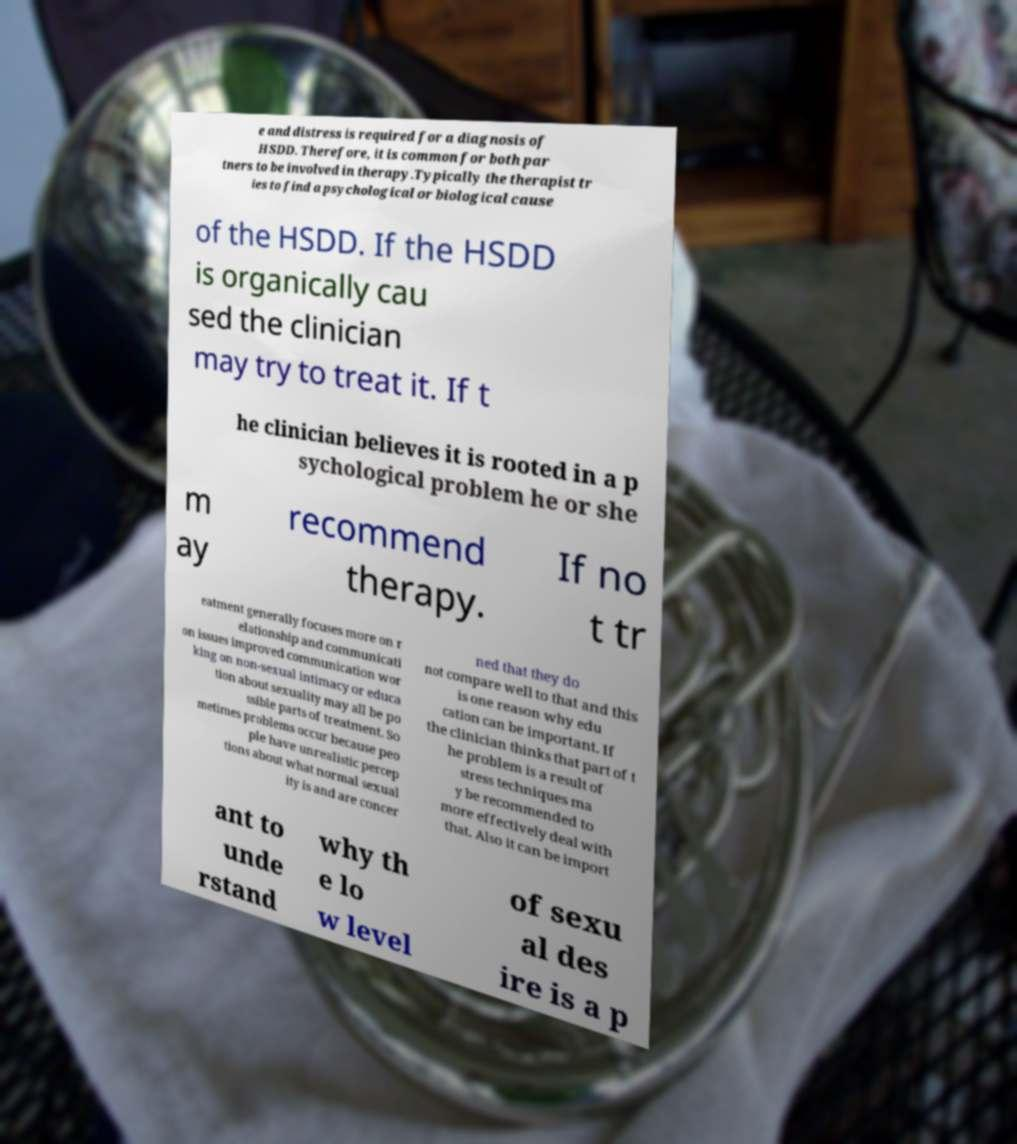Can you accurately transcribe the text from the provided image for me? e and distress is required for a diagnosis of HSDD. Therefore, it is common for both par tners to be involved in therapy.Typically the therapist tr ies to find a psychological or biological cause of the HSDD. If the HSDD is organically cau sed the clinician may try to treat it. If t he clinician believes it is rooted in a p sychological problem he or she m ay recommend therapy. If no t tr eatment generally focuses more on r elationship and communicati on issues improved communication wor king on non-sexual intimacy or educa tion about sexuality may all be po ssible parts of treatment. So metimes problems occur because peo ple have unrealistic percep tions about what normal sexual ity is and are concer ned that they do not compare well to that and this is one reason why edu cation can be important. If the clinician thinks that part of t he problem is a result of stress techniques ma y be recommended to more effectively deal with that. Also it can be import ant to unde rstand why th e lo w level of sexu al des ire is a p 